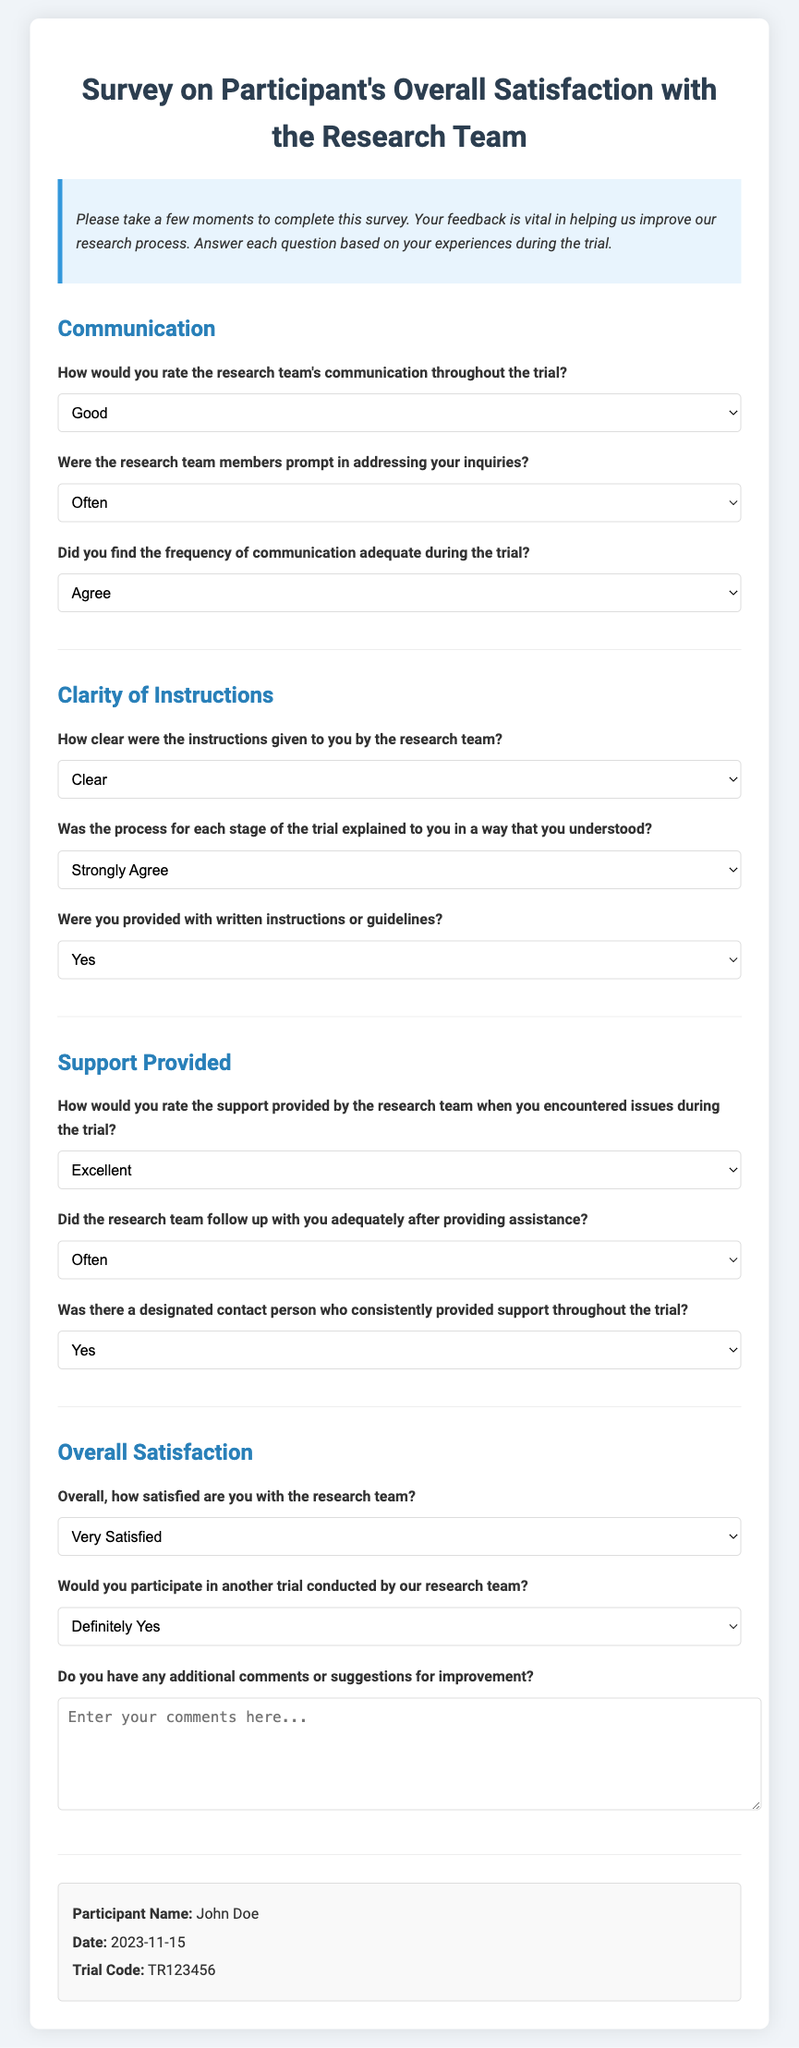What is the title of the survey? The title of the survey is presented at the top of the document in a prominent location.
Answer: Survey on Participant's Overall Satisfaction with the Research Team What date was the survey completed? The date is located in the participant information section towards the end of the document.
Answer: 2023-11-15 What is the participant's name? The participant's name can be found in the participant information section of the document.
Answer: John Doe How would the participant rate the support provided by the research team? This rating is given in the section on support provided, where a specific response is chosen from a set of options.
Answer: Excellent Did the participant receive written instructions or guidelines? The answer to this question is stated in the clarity of instructions section.
Answer: Yes How satisfied is the participant with the research team overall? The overall satisfaction question provides a clear assessment based on the selected option.
Answer: Very Satisfied Was there a designated contact person who provided support? This information is explicitly stated in the support provided section of the survey.
Answer: Yes How often were inquiries addressed by the research team? This frequency is mentioned in the communication section with a specific option chosen.
Answer: Often Would the participant join another trial conducted by the team? The participant provides this information in the overall satisfaction section through a specific selection.
Answer: Definitely Yes 